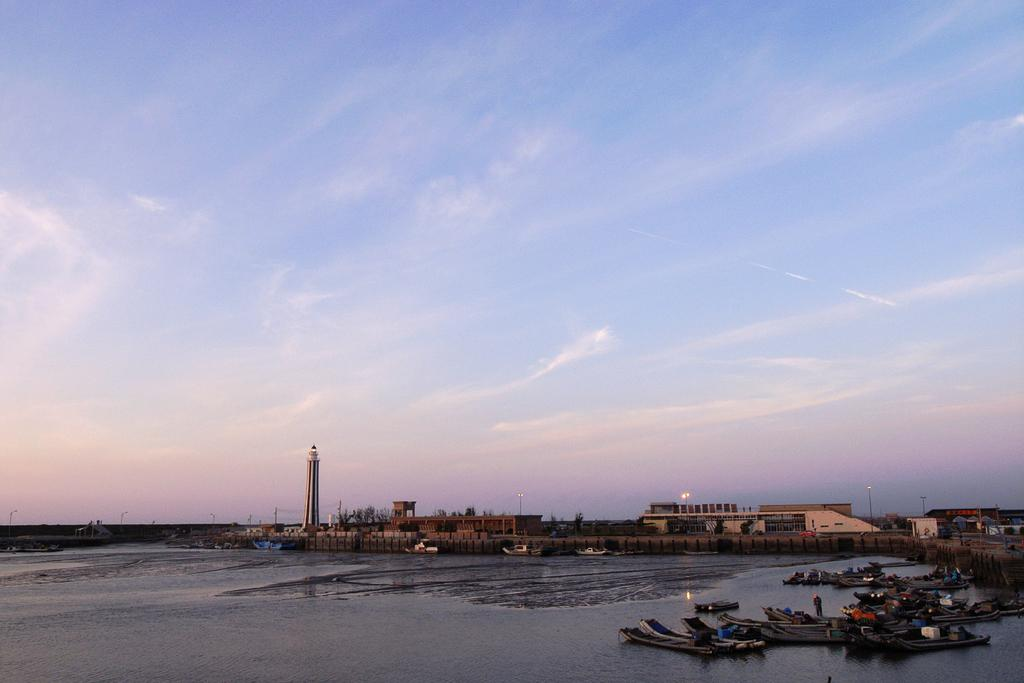What is the main element in the image? There is water in the image. What can be seen on the left side of the image? There are boats on the left side of the image. What structures are visible in the background of the image? There are buildings visible at the back of the image. What is visible at the top of the image? The sky is visible at the top of the image. Where are the cherries located in the image? There are no cherries present in the image. Can you see an ant crawling on the boats in the image? There is no ant visible in the image. 